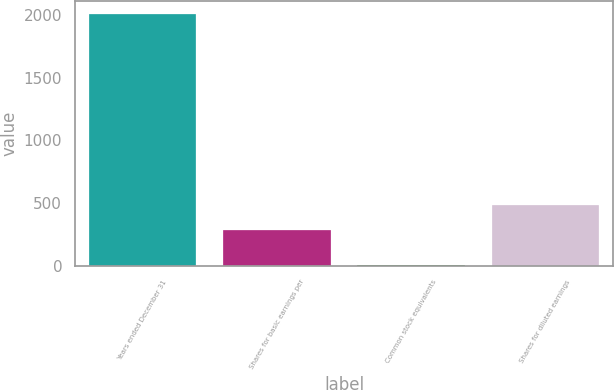<chart> <loc_0><loc_0><loc_500><loc_500><bar_chart><fcel>Years ended December 31<fcel>Shares for basic earnings per<fcel>Common stock equivalents<fcel>Shares for diluted earnings<nl><fcel>2009<fcel>283.2<fcel>7.9<fcel>483.31<nl></chart> 